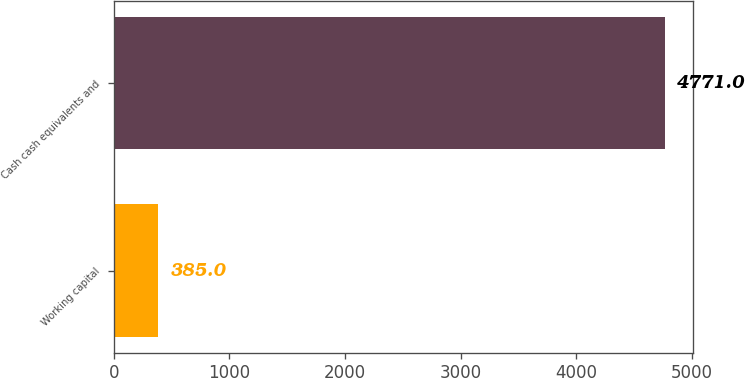<chart> <loc_0><loc_0><loc_500><loc_500><bar_chart><fcel>Working capital<fcel>Cash cash equivalents and<nl><fcel>385<fcel>4771<nl></chart> 